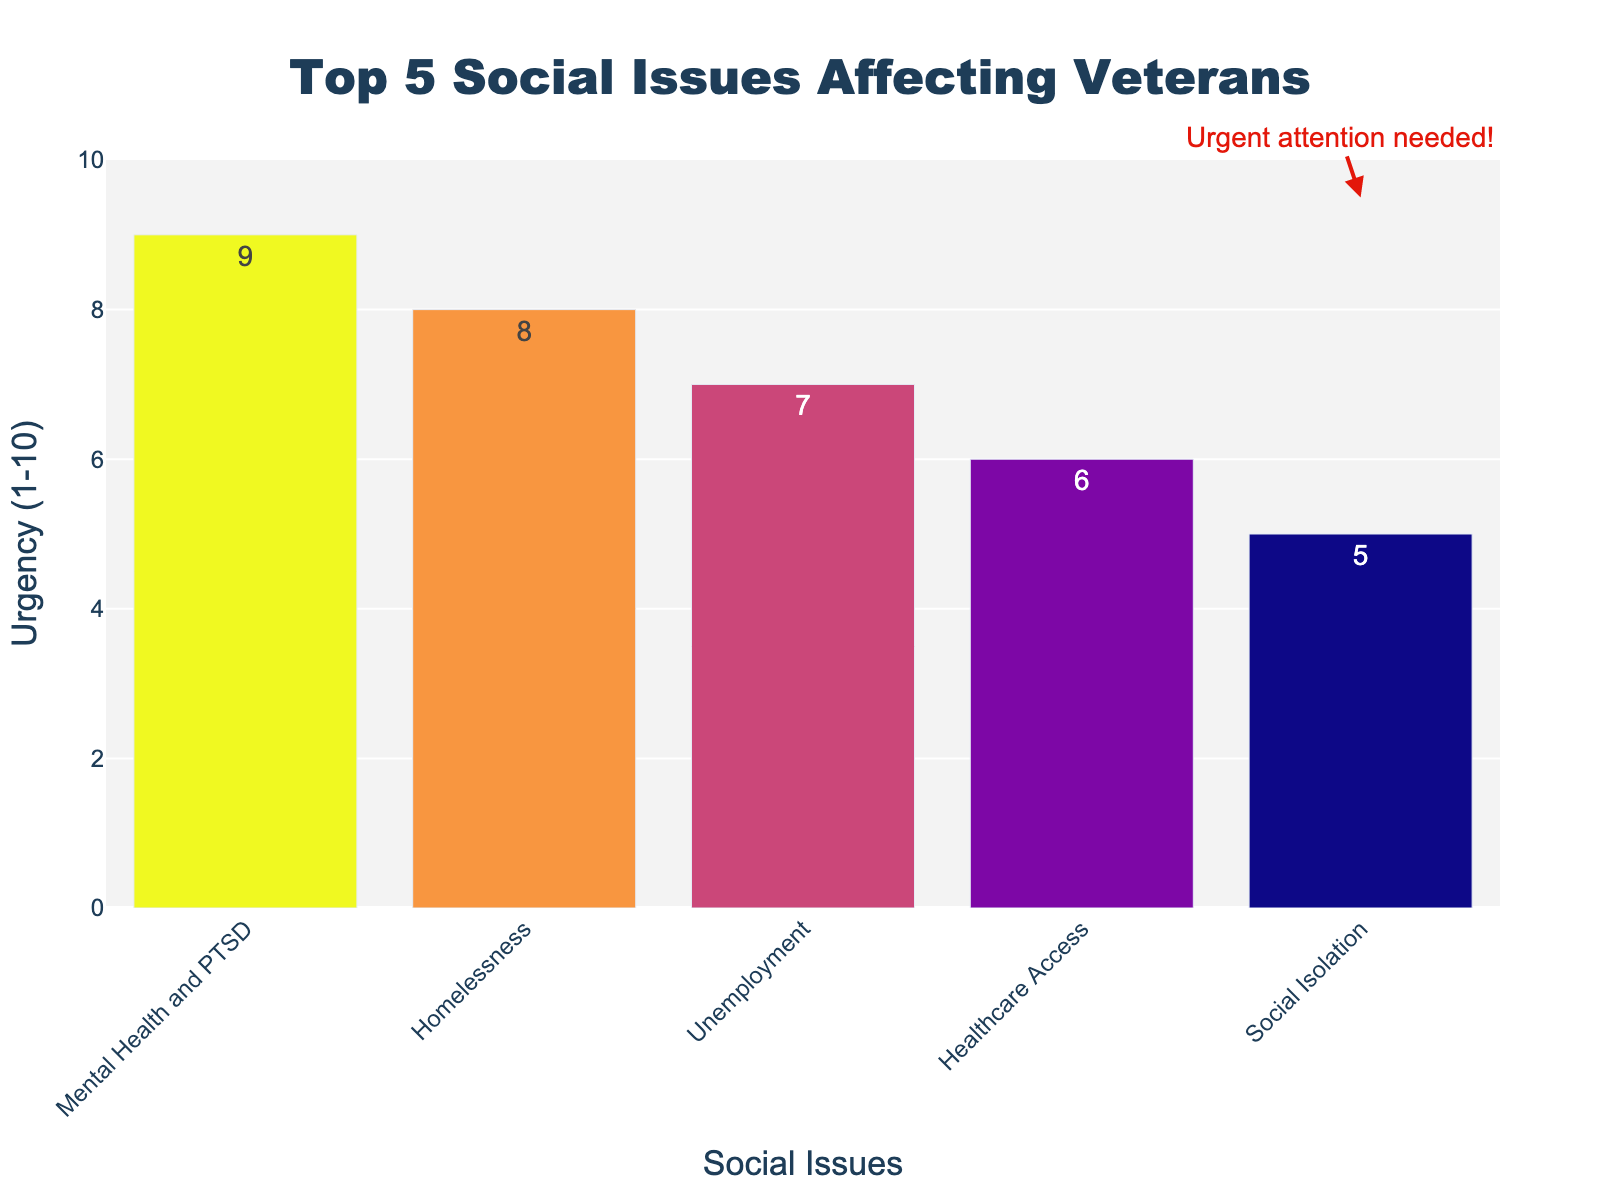What is the top social issue affecting veterans according to the chart? The highest bar on the chart represents the most pressing social issue. In this chart, "Mental Health and PTSD" has the highest bar with an urgency level of 9, indicating it is the top social issue.
Answer: Mental Health and PTSD Which two issues have the closest urgency levels? By comparing the height of the bars, "Unemployment" and "Healthcare Access" have very close urgency levels of 7 and 6, respectively.
Answer: Unemployment and Healthcare Access What is the difference in urgency between "Mental Health and PTSD" and "Social Isolation"? The urgency level for "Mental Health and PTSD" is 9, and for "Social Isolation" it is 5. The difference is calculated as 9 - 5 = 4.
Answer: 4 Which social issue needs the least urgent attention? The bar with the lowest height represents the least urgent issue. "Social Isolation" has the lowest bar with an urgency level of 5.
Answer: Social Isolation If you sum the urgency levels of "Homelessness" and "Unemployment", what will be the total? The urgency level for "Homelessness" is 8, and for "Unemployment" it is 7. The total is calculated as 8 + 7 = 15.
Answer: 15 Which issue has an urgency level two points greater than "Healthcare Access"? "Healthcare Access" has an urgency level of 6. Adding 2 points gives 6 + 2 = 8, which corresponds to "Homelessness".
Answer: Homelessness Is the urgency of "Social Isolation" more or less than half of the urgency of "Mental Health and PTSD"? The urgency of "Mental Health and PTSD" is 9, and half of 9 is 4.5. The urgency of "Social Isolation" is 5, which is more than 4.5.
Answer: More How many issues have an urgency level greater than 6? By observing the chart, there are three issues with an urgency higher than 6: "Mental Health and PTSD" (9), "Homelessness" (8), and "Unemployment" (7).
Answer: 3 Which issue has a visual annotation indicating its importance? The annotation "Urgent attention needed!" is shown beside the "Social Isolation" bar.
Answer: Social Isolation 